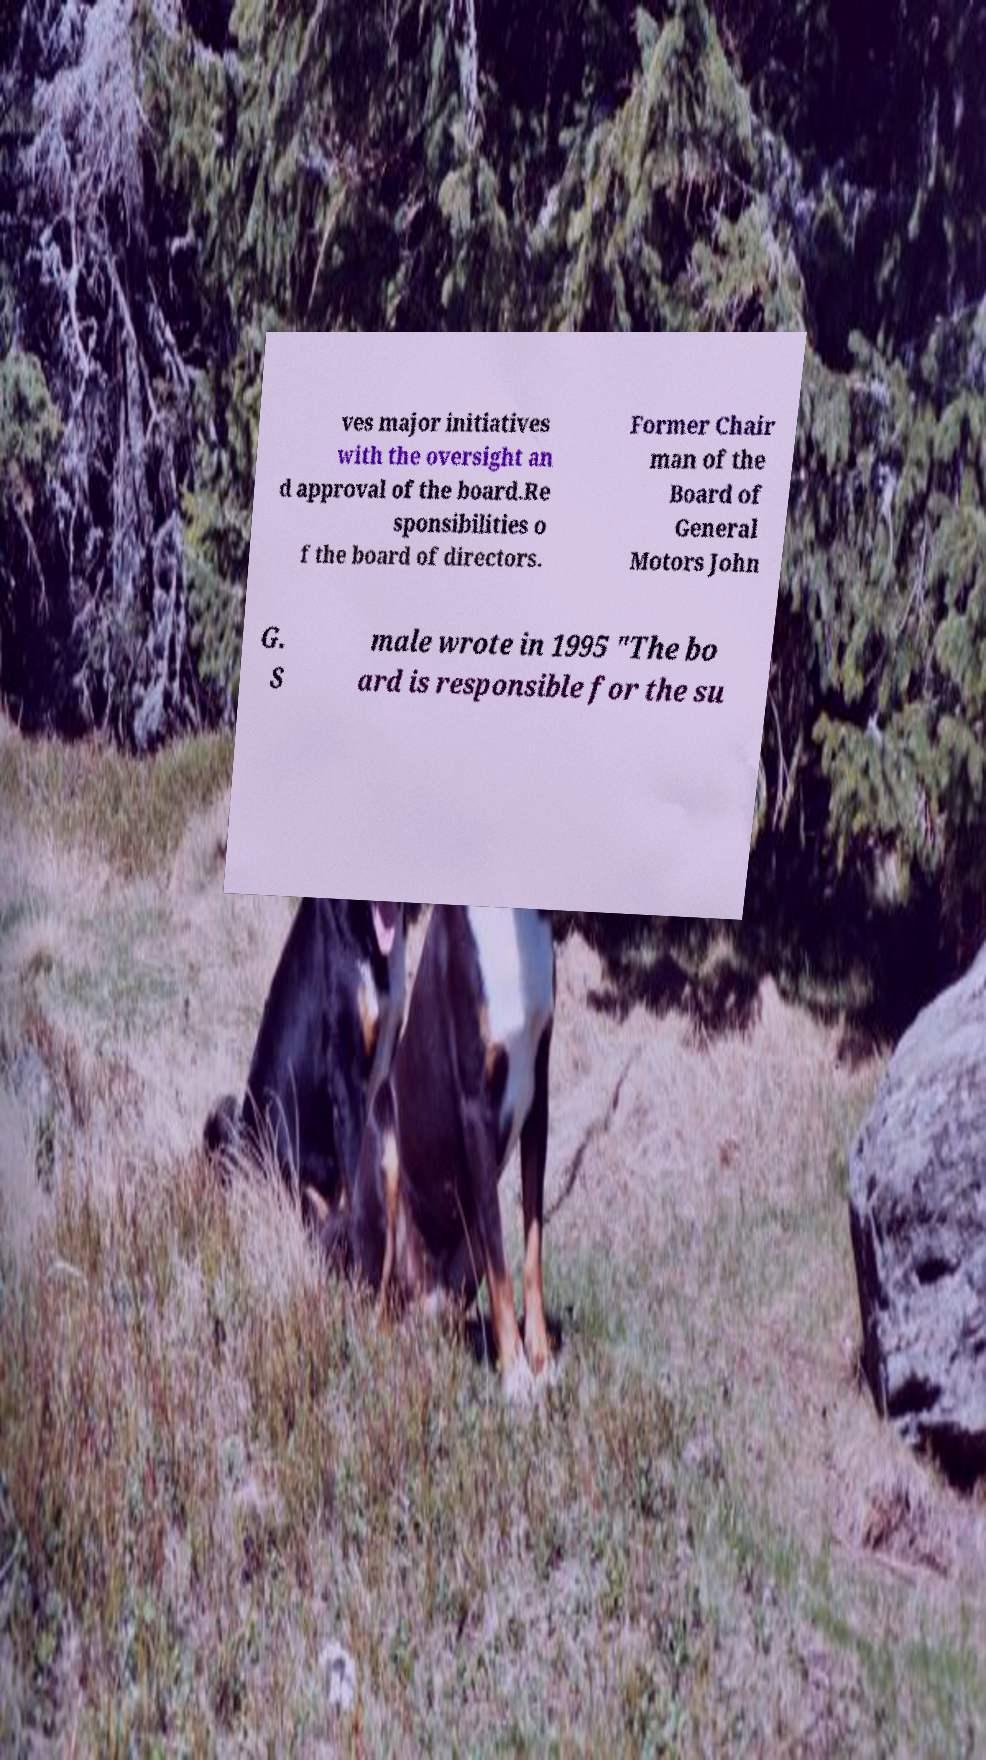For documentation purposes, I need the text within this image transcribed. Could you provide that? ves major initiatives with the oversight an d approval of the board.Re sponsibilities o f the board of directors. Former Chair man of the Board of General Motors John G. S male wrote in 1995 "The bo ard is responsible for the su 